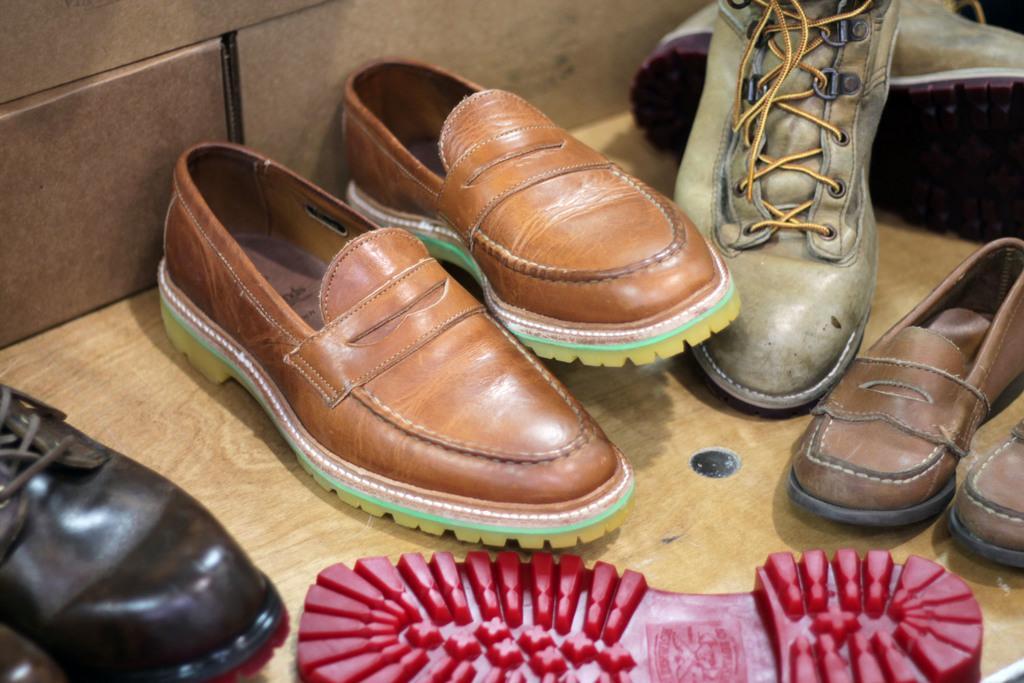Please provide a concise description of this image. In this image we can see some shoes on the wooden surface, also we can see the wall. 